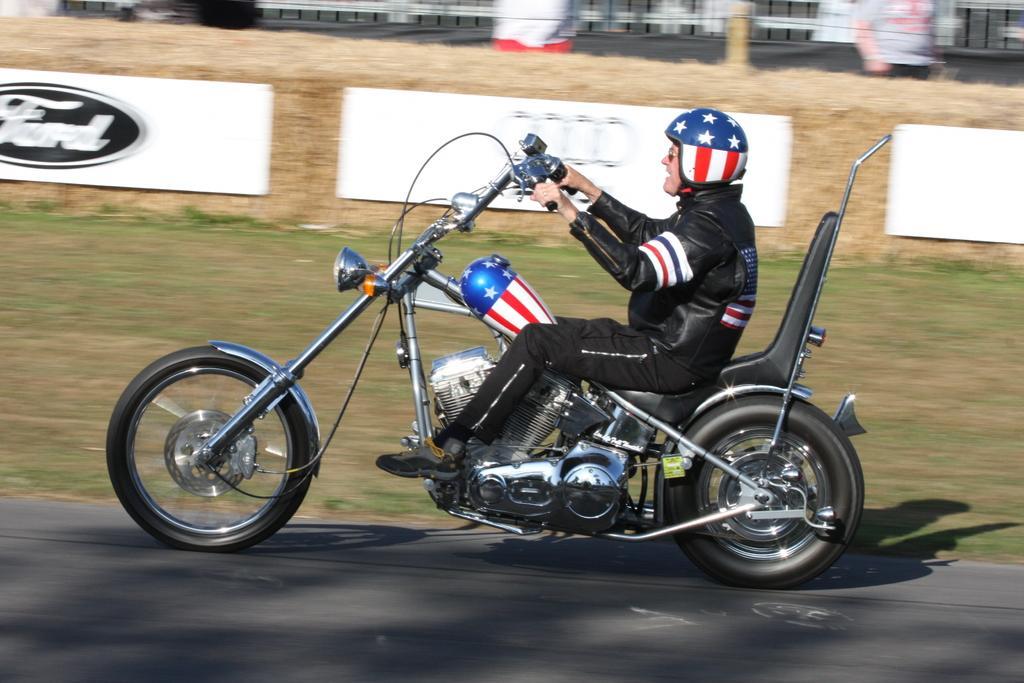Describe this image in one or two sentences. There is one man riding a bike on the road as we can see in the middle of this image. There is a grassy land in the background. We can see there are some boards beside to this person. It seems like there is a fencing at the top of this image. There is one person standing at the top right corner of this image. 